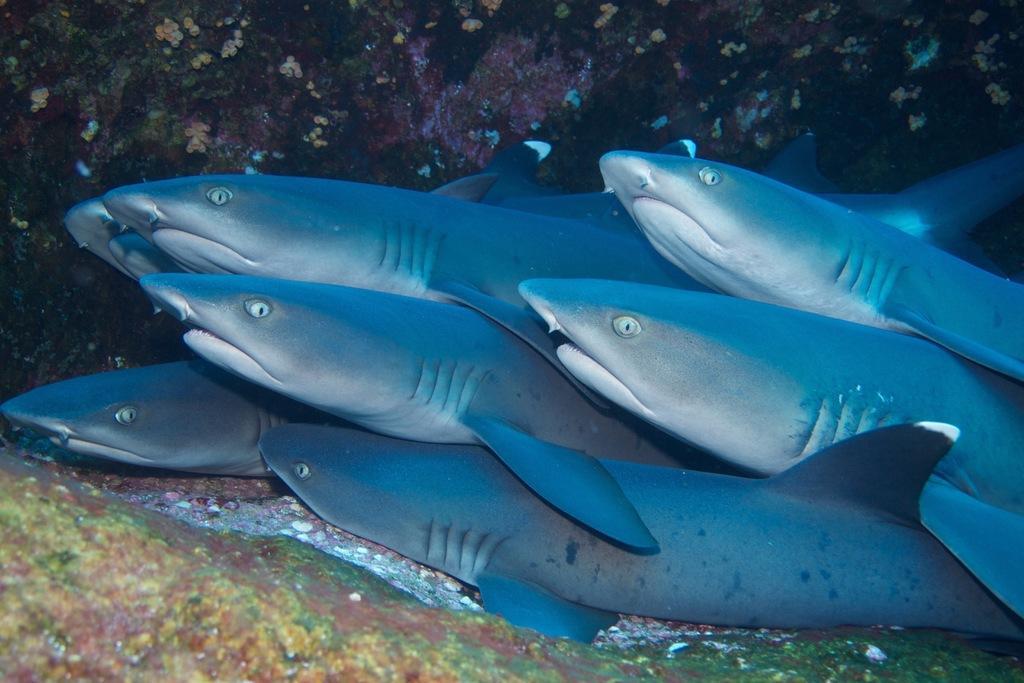Please provide a concise description of this image. In this image we can see there are some fishes in the water. 